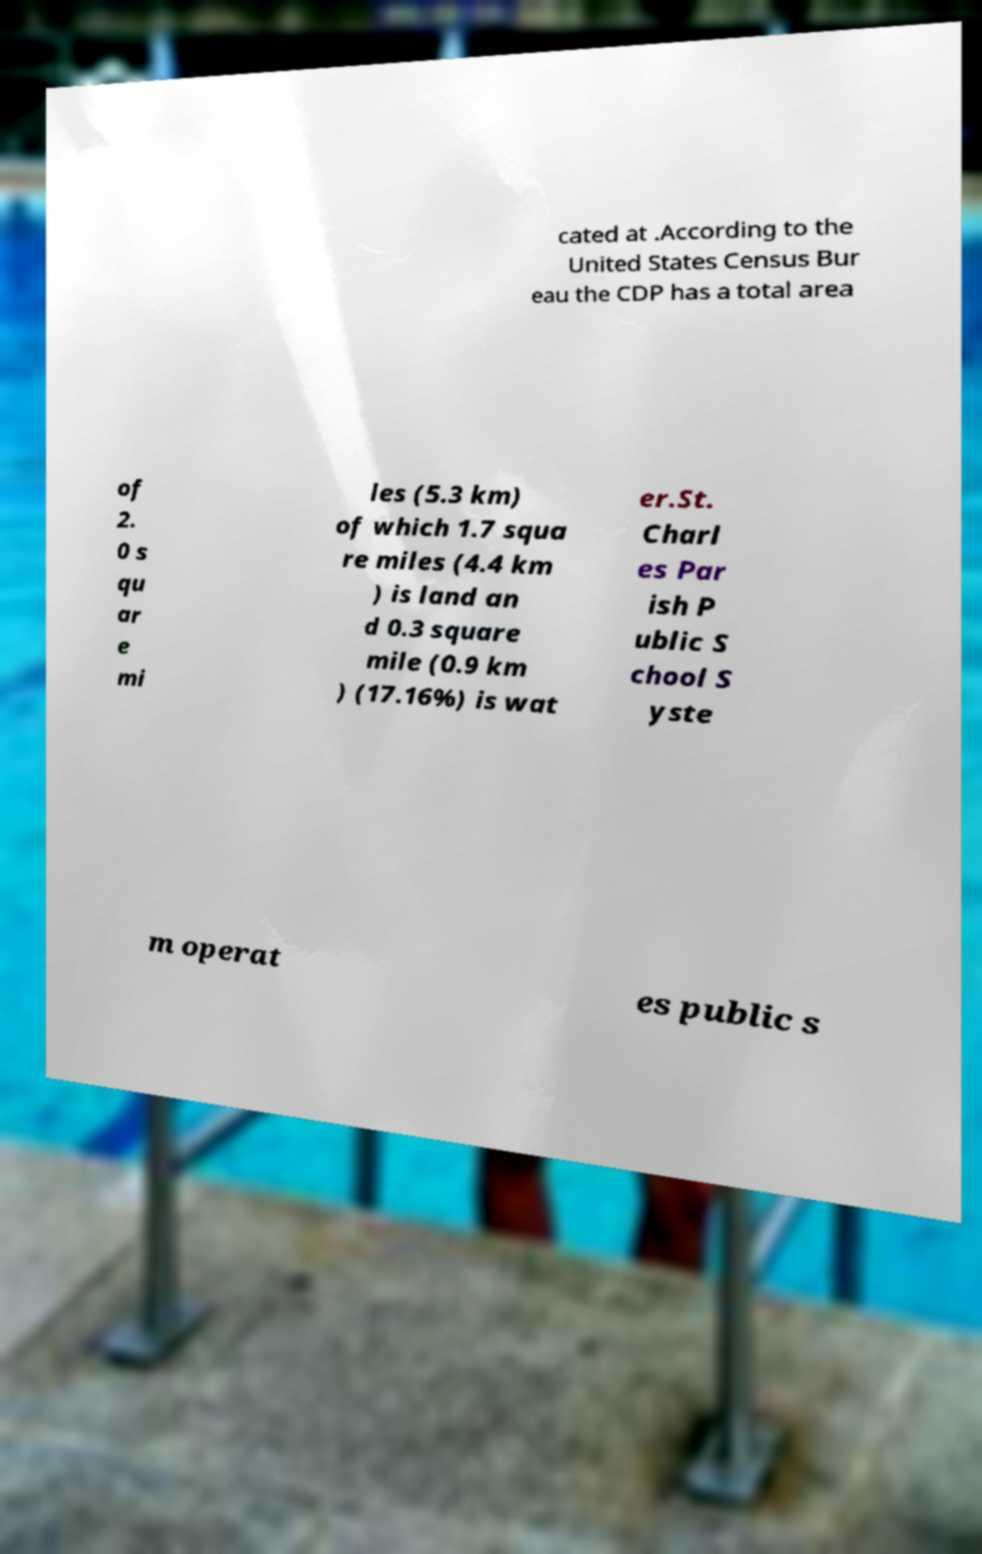Please read and relay the text visible in this image. What does it say? cated at .According to the United States Census Bur eau the CDP has a total area of 2. 0 s qu ar e mi les (5.3 km) of which 1.7 squa re miles (4.4 km ) is land an d 0.3 square mile (0.9 km ) (17.16%) is wat er.St. Charl es Par ish P ublic S chool S yste m operat es public s 